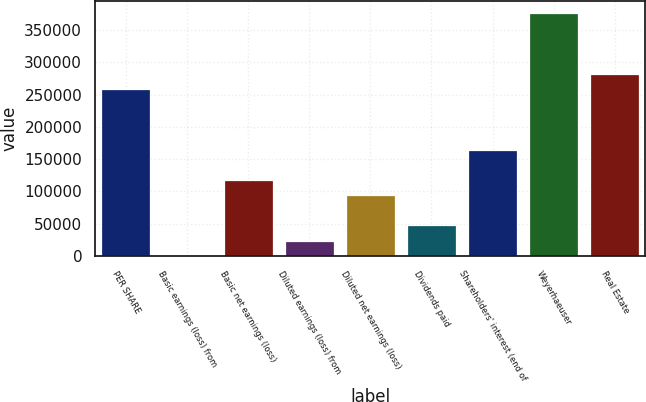Convert chart to OTSL. <chart><loc_0><loc_0><loc_500><loc_500><bar_chart><fcel>PER SHARE<fcel>Basic earnings (loss) from<fcel>Basic net earnings (loss)<fcel>Diluted earnings (loss) from<fcel>Diluted net earnings (loss)<fcel>Dividends paid<fcel>Shareholders' interest (end of<fcel>Weyerhaeuser<fcel>Real Estate<nl><fcel>258998<fcel>1.06<fcel>117727<fcel>23546.2<fcel>94181.8<fcel>47091.4<fcel>164817<fcel>376724<fcel>282543<nl></chart> 